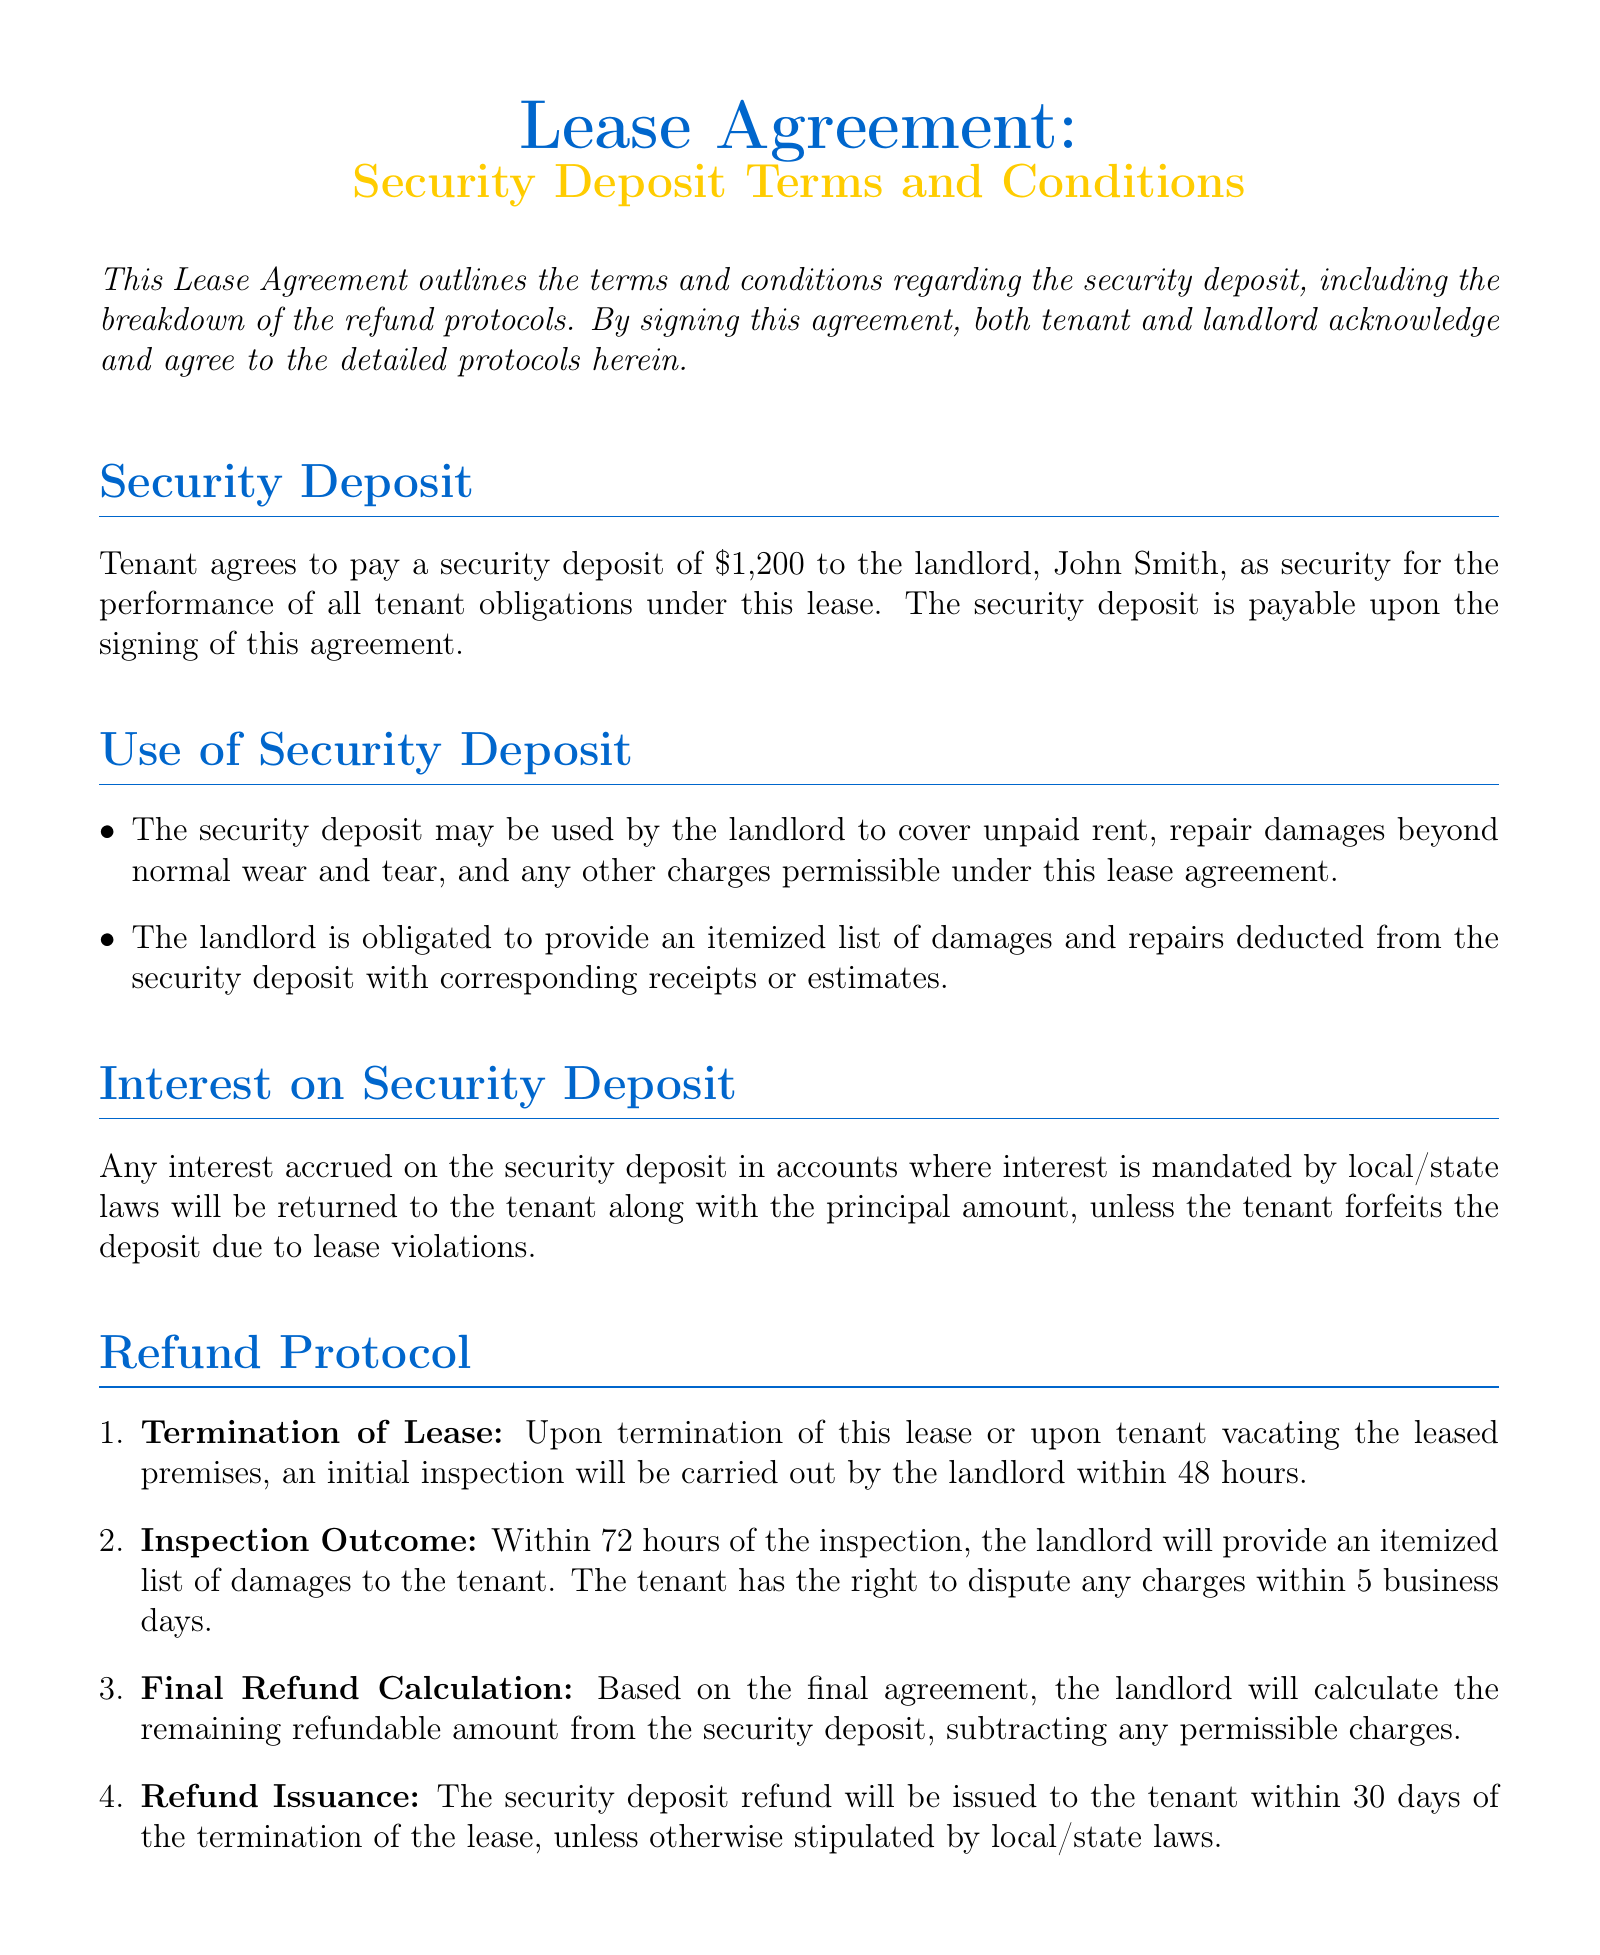What is the amount of the security deposit? The security deposit amount is explicitly stated in the document as $1,200.
Answer: $1,200 Who is the landlord named in the lease agreement? The lease agreement specifies the landlord's name as John Smith.
Answer: John Smith How many hours after termination does the landlord conduct the initial inspection? According to the refund protocol, the landlord conducts the initial inspection within 48 hours after termination.
Answer: 48 hours What is the timeframe for the tenant to dispute charges after the itemized list is provided? The tenant has the right to dispute any charges within 5 business days after receiving the itemized list of damages.
Answer: 5 business days Within how many days will the security deposit refund be issued? The document states that the security deposit refund will be issued within 30 days of termination, unless otherwise stipulated.
Answer: 30 days What must the landlord provide if they make deductions from the security deposit? The landlord is obligated to provide an itemized list of damages and repairs along with corresponding receipts or estimates.
Answer: Itemized list of damages What is the first step in the refund protocol following lease termination? The initial inspection by the landlord is the first step outlined in the refund protocol after lease termination.
Answer: Initial inspection What type of resolution process is agreed upon for disputes regarding the security deposit? The document states that both parties agree to seek mediation from the Johnson County Mediation Center for dispute resolution.
Answer: Mediation 